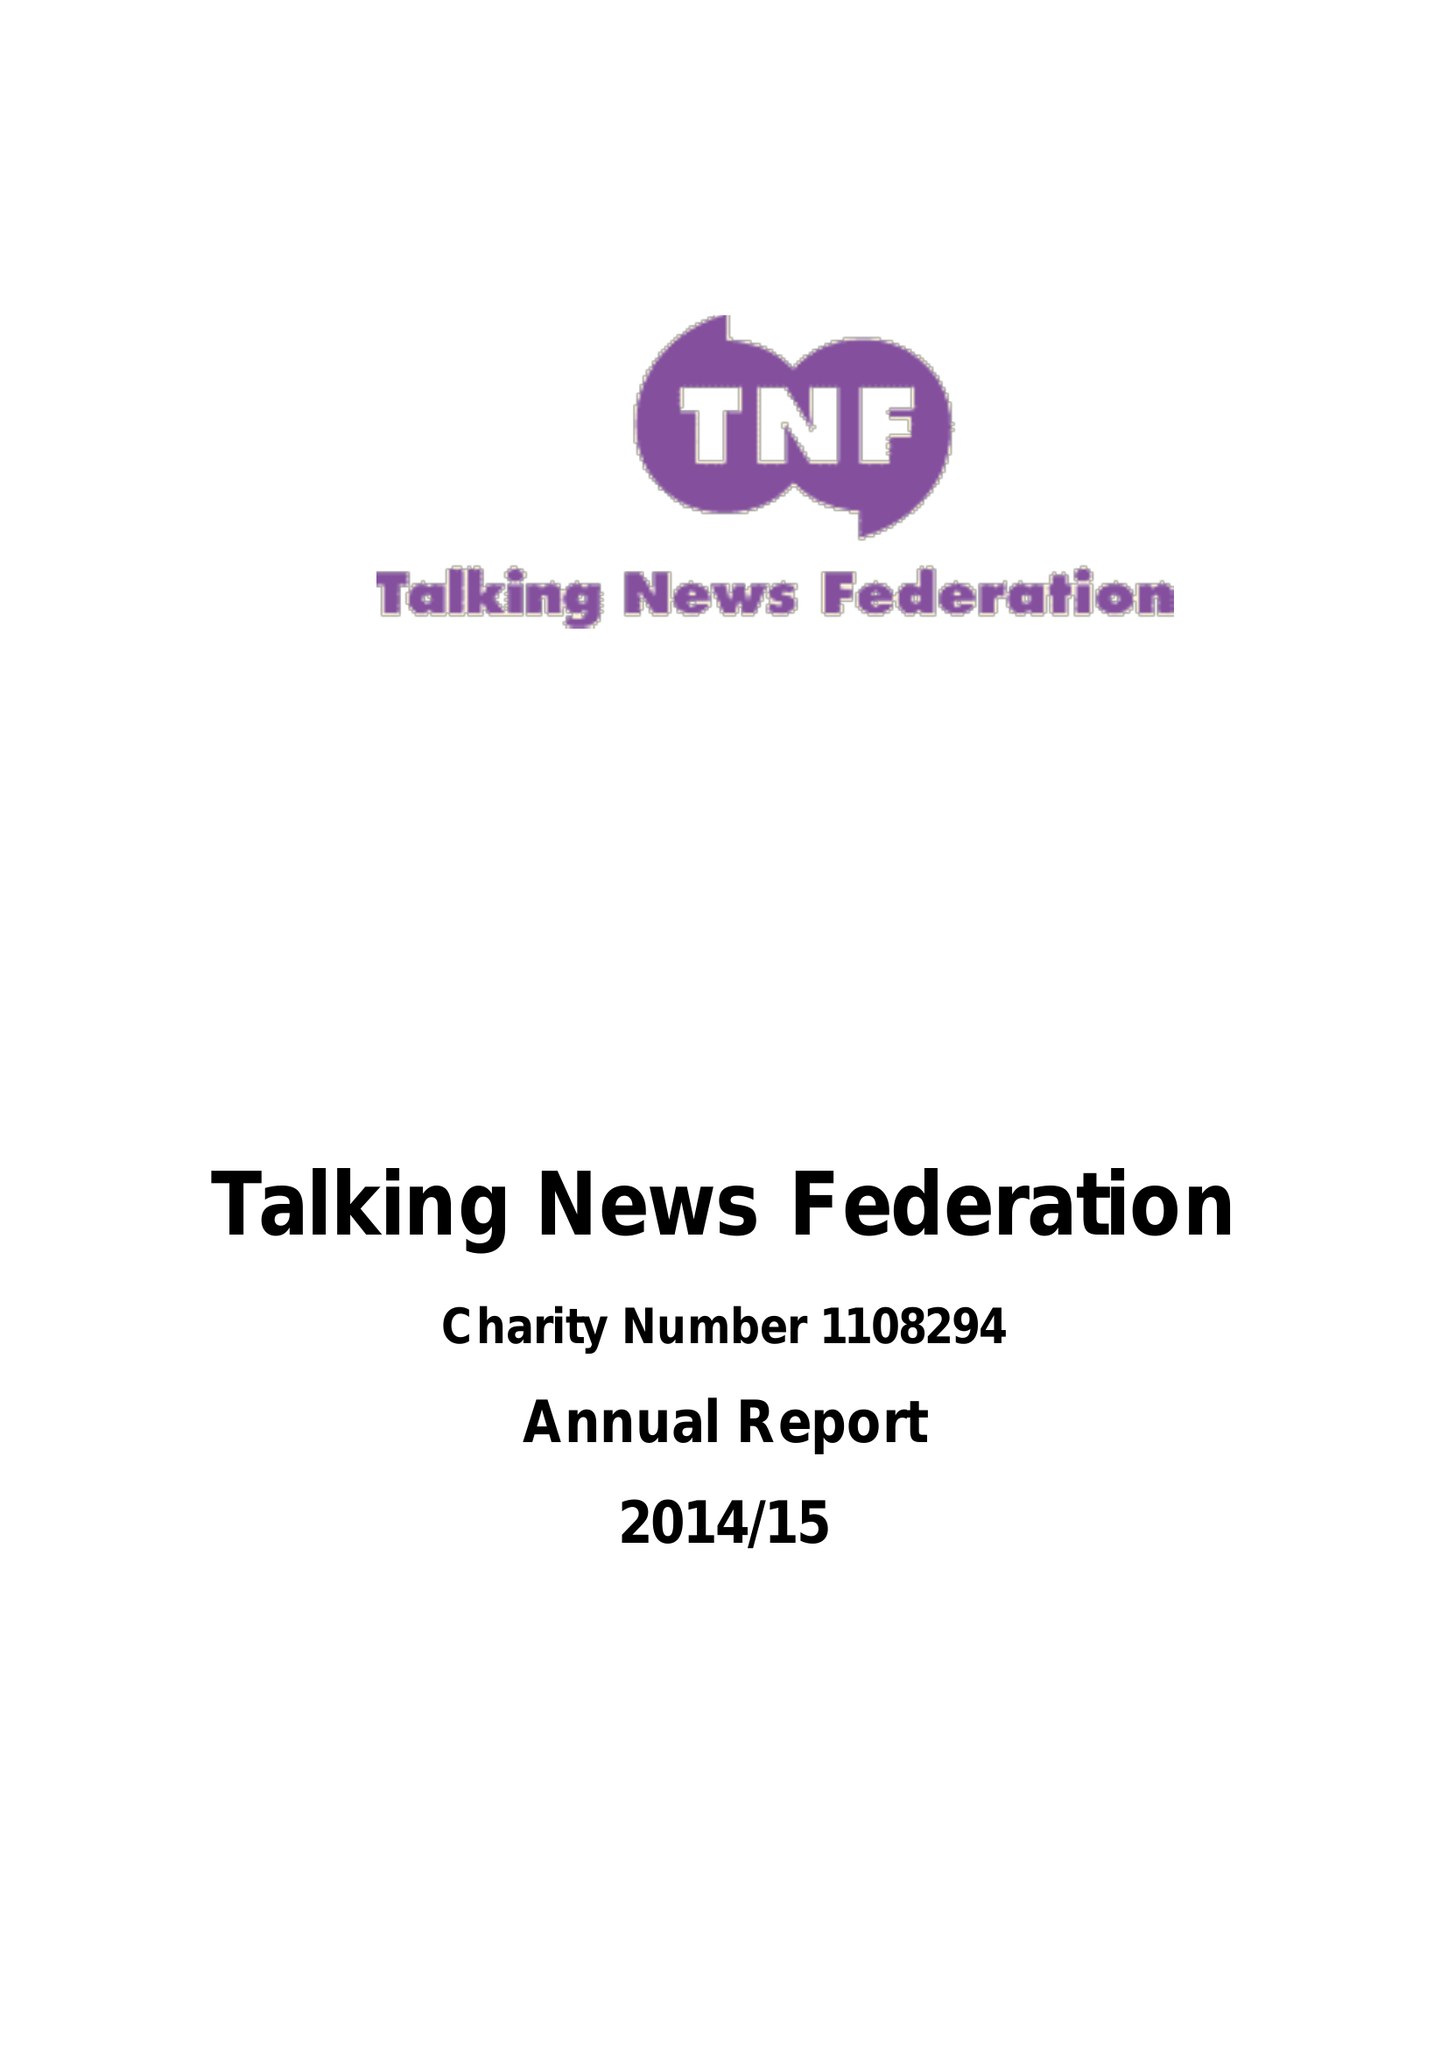What is the value for the address__postcode?
Answer the question using a single word or phrase. SN1 3BU 